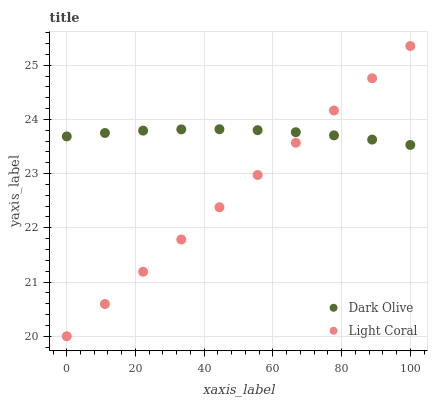Does Light Coral have the minimum area under the curve?
Answer yes or no. Yes. Does Dark Olive have the maximum area under the curve?
Answer yes or no. Yes. Does Dark Olive have the minimum area under the curve?
Answer yes or no. No. Is Light Coral the smoothest?
Answer yes or no. Yes. Is Dark Olive the roughest?
Answer yes or no. Yes. Is Dark Olive the smoothest?
Answer yes or no. No. Does Light Coral have the lowest value?
Answer yes or no. Yes. Does Dark Olive have the lowest value?
Answer yes or no. No. Does Light Coral have the highest value?
Answer yes or no. Yes. Does Dark Olive have the highest value?
Answer yes or no. No. Does Light Coral intersect Dark Olive?
Answer yes or no. Yes. Is Light Coral less than Dark Olive?
Answer yes or no. No. Is Light Coral greater than Dark Olive?
Answer yes or no. No. 